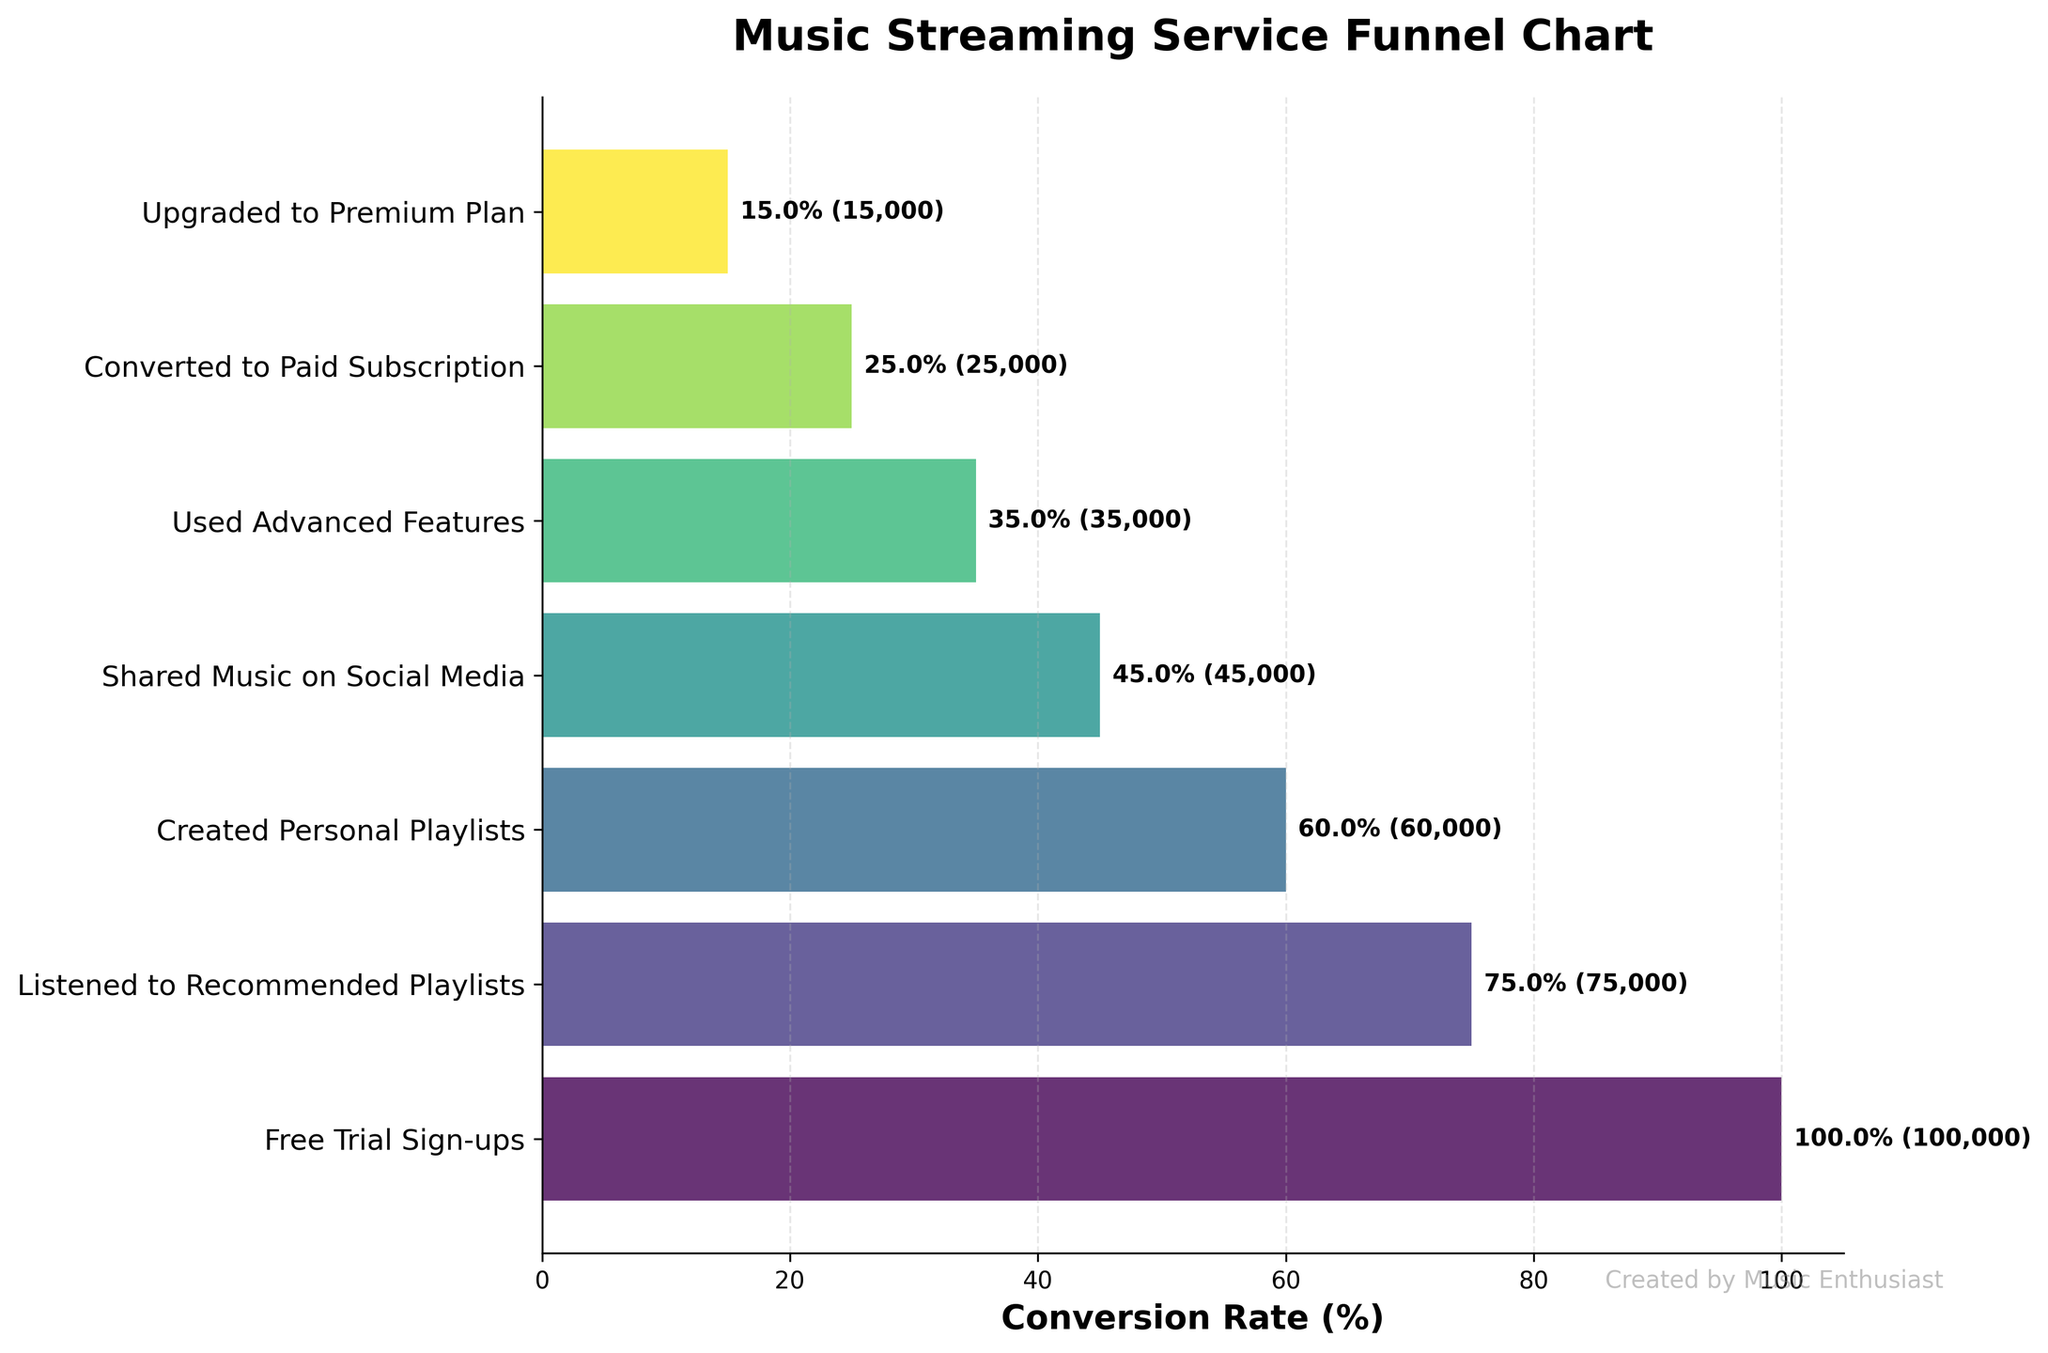How many users signed up for a free trial? According to the funnel chart, the number of users who signed up for a free trial is explicitly mentioned at the topmost stage, which is listed as 100,000.
Answer: 100,000 What is the conversion rate from free trial sign-ups to paid subscriptions, in percentage? The conversion rate is calculated by taking the number of users who converted to paid subscriptions (25,000) and dividing it by the number of users who signed up for a free trial (100,000), then multiplying the result by 100. This yields \( (25,000 / 100,000) \times 100 = 25\% \).
Answer: 25% Which stage sees the largest drop-off in user count? To determine the largest drop-off, we need to subtract sequential user counts and see which difference is the largest. The most significant drop-off is between the "Created Personal Playlists" stage (60,000) and the "Shared Music on Social Media" stage (45,000), a drop of 15,000 users.
Answer: Created Personal Playlists to Shared Music on Social Media How many users used advanced features? According to the funnel chart, the number of users who used advanced features is explicitly listed as the fifth stage, which is 35,000.
Answer: 35,000 What percentage of users shared music on social media? The percentage is calculated by taking the number of users who shared music on social media (45,000) and dividing it by the number of users who signed up for a free trial (100,000), then multiplying the result by 100. This yields \( (45,000 / 100,000) \times 100 = 45\% \).
Answer: 45% Are there more users who converted to paid subscriptions or upgraded to the premium plan? By comparing the two numbers, we see that there are 25,000 users who converted to paid subscriptions and 15,000 users who upgraded to the premium plan. Since 25,000 is greater than 15,000, there are more users who converted to paid subscriptions.
Answer: Converted to Paid Subscription What is the difference in user count between those who listened to recommended playlists and those who created personal playlists? To find the difference, subtract the number of users who created personal playlists (60,000) from those who listened to recommended playlists (75,000). This yields \( 75,000 - 60,000 = 15,000 \) users.
Answer: 15,000 What fraction of users who shared music on social media upgraded to the premium plan? To determine the fraction, we take the number of users who upgraded to the premium plan (15,000) and divide it by the number of users who shared music on social media (45,000). This yields \( 15,000 / 45,000 = 1/3 \).
Answer: 1/3 By how much does the conversion rate drop from using advanced features to upgrading to the premium plan, in percentage? The conversion rate for using advanced features is \( 35,000 / 100,000 \times 100 = 35\% \) and for the premium plan is \( 15,000 / 100,000 \times 100 = 15\% \). The drop is \( 35\% - 15\% = 20\% \).
Answer: 20% 